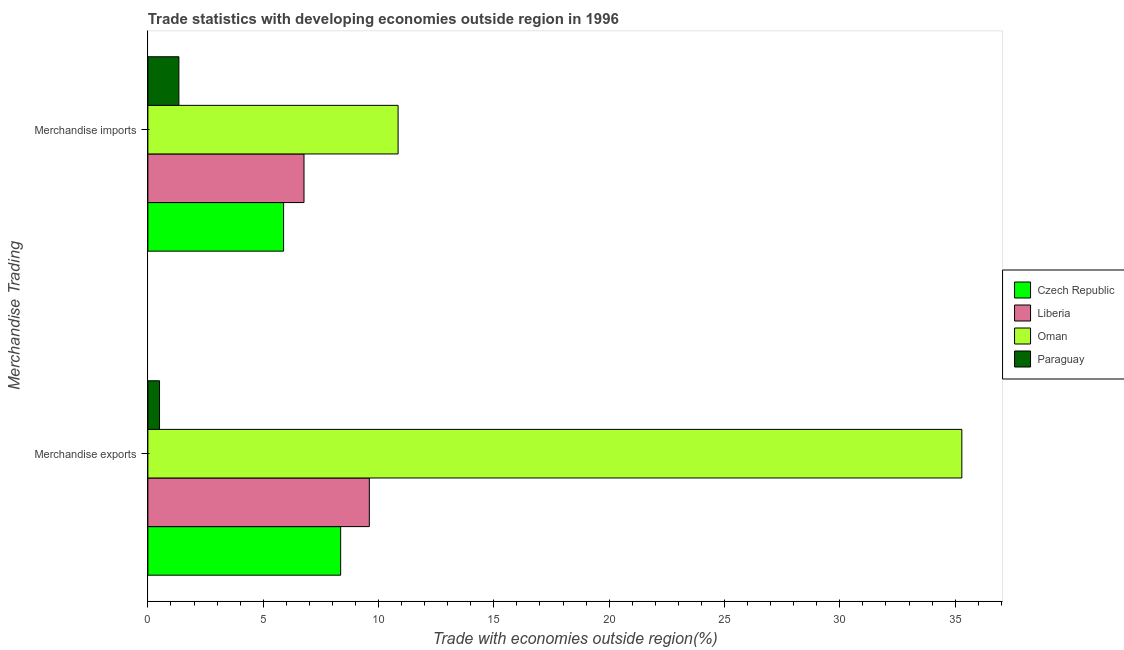How many different coloured bars are there?
Keep it short and to the point. 4. How many groups of bars are there?
Ensure brevity in your answer.  2. Are the number of bars per tick equal to the number of legend labels?
Keep it short and to the point. Yes. How many bars are there on the 2nd tick from the top?
Ensure brevity in your answer.  4. What is the merchandise exports in Liberia?
Ensure brevity in your answer.  9.6. Across all countries, what is the maximum merchandise imports?
Your answer should be compact. 10.85. Across all countries, what is the minimum merchandise imports?
Provide a succinct answer. 1.35. In which country was the merchandise exports maximum?
Offer a terse response. Oman. In which country was the merchandise imports minimum?
Make the answer very short. Paraguay. What is the total merchandise imports in the graph?
Offer a terse response. 24.85. What is the difference between the merchandise exports in Paraguay and that in Czech Republic?
Keep it short and to the point. -7.85. What is the difference between the merchandise imports in Czech Republic and the merchandise exports in Liberia?
Make the answer very short. -3.72. What is the average merchandise exports per country?
Make the answer very short. 13.44. What is the difference between the merchandise imports and merchandise exports in Czech Republic?
Offer a terse response. -2.47. What is the ratio of the merchandise exports in Czech Republic to that in Oman?
Your answer should be compact. 0.24. In how many countries, is the merchandise imports greater than the average merchandise imports taken over all countries?
Provide a short and direct response. 2. What does the 2nd bar from the top in Merchandise exports represents?
Your response must be concise. Oman. What does the 4th bar from the bottom in Merchandise imports represents?
Your answer should be compact. Paraguay. What is the difference between two consecutive major ticks on the X-axis?
Your answer should be very brief. 5. How many legend labels are there?
Your response must be concise. 4. What is the title of the graph?
Provide a short and direct response. Trade statistics with developing economies outside region in 1996. What is the label or title of the X-axis?
Give a very brief answer. Trade with economies outside region(%). What is the label or title of the Y-axis?
Ensure brevity in your answer.  Merchandise Trading. What is the Trade with economies outside region(%) of Czech Republic in Merchandise exports?
Your response must be concise. 8.36. What is the Trade with economies outside region(%) in Liberia in Merchandise exports?
Your response must be concise. 9.6. What is the Trade with economies outside region(%) in Oman in Merchandise exports?
Your answer should be compact. 35.29. What is the Trade with economies outside region(%) of Paraguay in Merchandise exports?
Make the answer very short. 0.51. What is the Trade with economies outside region(%) of Czech Republic in Merchandise imports?
Provide a short and direct response. 5.88. What is the Trade with economies outside region(%) in Liberia in Merchandise imports?
Your answer should be very brief. 6.77. What is the Trade with economies outside region(%) of Oman in Merchandise imports?
Make the answer very short. 10.85. What is the Trade with economies outside region(%) of Paraguay in Merchandise imports?
Provide a short and direct response. 1.35. Across all Merchandise Trading, what is the maximum Trade with economies outside region(%) in Czech Republic?
Offer a terse response. 8.36. Across all Merchandise Trading, what is the maximum Trade with economies outside region(%) in Liberia?
Ensure brevity in your answer.  9.6. Across all Merchandise Trading, what is the maximum Trade with economies outside region(%) of Oman?
Ensure brevity in your answer.  35.29. Across all Merchandise Trading, what is the maximum Trade with economies outside region(%) of Paraguay?
Give a very brief answer. 1.35. Across all Merchandise Trading, what is the minimum Trade with economies outside region(%) of Czech Republic?
Provide a short and direct response. 5.88. Across all Merchandise Trading, what is the minimum Trade with economies outside region(%) in Liberia?
Give a very brief answer. 6.77. Across all Merchandise Trading, what is the minimum Trade with economies outside region(%) in Oman?
Your answer should be very brief. 10.85. Across all Merchandise Trading, what is the minimum Trade with economies outside region(%) in Paraguay?
Provide a succinct answer. 0.51. What is the total Trade with economies outside region(%) of Czech Republic in the graph?
Keep it short and to the point. 14.24. What is the total Trade with economies outside region(%) of Liberia in the graph?
Offer a very short reply. 16.37. What is the total Trade with economies outside region(%) in Oman in the graph?
Ensure brevity in your answer.  46.14. What is the total Trade with economies outside region(%) in Paraguay in the graph?
Offer a terse response. 1.85. What is the difference between the Trade with economies outside region(%) of Czech Republic in Merchandise exports and that in Merchandise imports?
Your answer should be very brief. 2.47. What is the difference between the Trade with economies outside region(%) of Liberia in Merchandise exports and that in Merchandise imports?
Offer a very short reply. 2.83. What is the difference between the Trade with economies outside region(%) in Oman in Merchandise exports and that in Merchandise imports?
Ensure brevity in your answer.  24.44. What is the difference between the Trade with economies outside region(%) of Paraguay in Merchandise exports and that in Merchandise imports?
Provide a succinct answer. -0.84. What is the difference between the Trade with economies outside region(%) of Czech Republic in Merchandise exports and the Trade with economies outside region(%) of Liberia in Merchandise imports?
Your response must be concise. 1.59. What is the difference between the Trade with economies outside region(%) of Czech Republic in Merchandise exports and the Trade with economies outside region(%) of Oman in Merchandise imports?
Offer a very short reply. -2.49. What is the difference between the Trade with economies outside region(%) in Czech Republic in Merchandise exports and the Trade with economies outside region(%) in Paraguay in Merchandise imports?
Give a very brief answer. 7.01. What is the difference between the Trade with economies outside region(%) of Liberia in Merchandise exports and the Trade with economies outside region(%) of Oman in Merchandise imports?
Offer a terse response. -1.25. What is the difference between the Trade with economies outside region(%) of Liberia in Merchandise exports and the Trade with economies outside region(%) of Paraguay in Merchandise imports?
Ensure brevity in your answer.  8.26. What is the difference between the Trade with economies outside region(%) of Oman in Merchandise exports and the Trade with economies outside region(%) of Paraguay in Merchandise imports?
Offer a very short reply. 33.94. What is the average Trade with economies outside region(%) in Czech Republic per Merchandise Trading?
Provide a short and direct response. 7.12. What is the average Trade with economies outside region(%) in Liberia per Merchandise Trading?
Make the answer very short. 8.19. What is the average Trade with economies outside region(%) of Oman per Merchandise Trading?
Offer a very short reply. 23.07. What is the average Trade with economies outside region(%) in Paraguay per Merchandise Trading?
Your response must be concise. 0.93. What is the difference between the Trade with economies outside region(%) of Czech Republic and Trade with economies outside region(%) of Liberia in Merchandise exports?
Offer a terse response. -1.24. What is the difference between the Trade with economies outside region(%) of Czech Republic and Trade with economies outside region(%) of Oman in Merchandise exports?
Ensure brevity in your answer.  -26.93. What is the difference between the Trade with economies outside region(%) of Czech Republic and Trade with economies outside region(%) of Paraguay in Merchandise exports?
Provide a short and direct response. 7.85. What is the difference between the Trade with economies outside region(%) of Liberia and Trade with economies outside region(%) of Oman in Merchandise exports?
Ensure brevity in your answer.  -25.69. What is the difference between the Trade with economies outside region(%) of Liberia and Trade with economies outside region(%) of Paraguay in Merchandise exports?
Provide a short and direct response. 9.1. What is the difference between the Trade with economies outside region(%) of Oman and Trade with economies outside region(%) of Paraguay in Merchandise exports?
Your answer should be very brief. 34.78. What is the difference between the Trade with economies outside region(%) of Czech Republic and Trade with economies outside region(%) of Liberia in Merchandise imports?
Your answer should be compact. -0.89. What is the difference between the Trade with economies outside region(%) in Czech Republic and Trade with economies outside region(%) in Oman in Merchandise imports?
Provide a succinct answer. -4.96. What is the difference between the Trade with economies outside region(%) in Czech Republic and Trade with economies outside region(%) in Paraguay in Merchandise imports?
Provide a succinct answer. 4.54. What is the difference between the Trade with economies outside region(%) in Liberia and Trade with economies outside region(%) in Oman in Merchandise imports?
Make the answer very short. -4.08. What is the difference between the Trade with economies outside region(%) in Liberia and Trade with economies outside region(%) in Paraguay in Merchandise imports?
Offer a terse response. 5.42. What is the difference between the Trade with economies outside region(%) of Oman and Trade with economies outside region(%) of Paraguay in Merchandise imports?
Provide a short and direct response. 9.5. What is the ratio of the Trade with economies outside region(%) in Czech Republic in Merchandise exports to that in Merchandise imports?
Keep it short and to the point. 1.42. What is the ratio of the Trade with economies outside region(%) of Liberia in Merchandise exports to that in Merchandise imports?
Your response must be concise. 1.42. What is the ratio of the Trade with economies outside region(%) of Oman in Merchandise exports to that in Merchandise imports?
Ensure brevity in your answer.  3.25. What is the ratio of the Trade with economies outside region(%) in Paraguay in Merchandise exports to that in Merchandise imports?
Provide a succinct answer. 0.38. What is the difference between the highest and the second highest Trade with economies outside region(%) in Czech Republic?
Ensure brevity in your answer.  2.47. What is the difference between the highest and the second highest Trade with economies outside region(%) of Liberia?
Your answer should be compact. 2.83. What is the difference between the highest and the second highest Trade with economies outside region(%) in Oman?
Your answer should be compact. 24.44. What is the difference between the highest and the second highest Trade with economies outside region(%) of Paraguay?
Offer a terse response. 0.84. What is the difference between the highest and the lowest Trade with economies outside region(%) in Czech Republic?
Provide a succinct answer. 2.47. What is the difference between the highest and the lowest Trade with economies outside region(%) of Liberia?
Offer a very short reply. 2.83. What is the difference between the highest and the lowest Trade with economies outside region(%) of Oman?
Provide a succinct answer. 24.44. What is the difference between the highest and the lowest Trade with economies outside region(%) in Paraguay?
Your answer should be very brief. 0.84. 